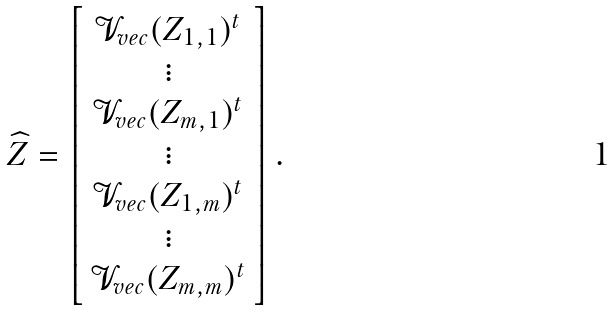<formula> <loc_0><loc_0><loc_500><loc_500>\widehat { Z } = \left [ \begin{array} [ c ] { c } \mathcal { V } _ { v e c } ( Z _ { 1 , 1 } ) ^ { t } \\ \vdots \\ \mathcal { V } _ { v e c } ( Z _ { m , 1 } ) ^ { t } \\ \vdots \\ \mathcal { V } _ { v e c } ( Z _ { 1 , m } ) ^ { t } \\ \vdots \\ \mathcal { V } _ { v e c } ( Z _ { m , m } ) ^ { t } \end{array} \right ] .</formula> 